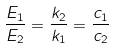Convert formula to latex. <formula><loc_0><loc_0><loc_500><loc_500>\frac { E _ { 1 } } { E _ { 2 } } = \frac { k _ { 2 } } { k _ { 1 } } = \frac { c _ { 1 } } { c _ { 2 } }</formula> 